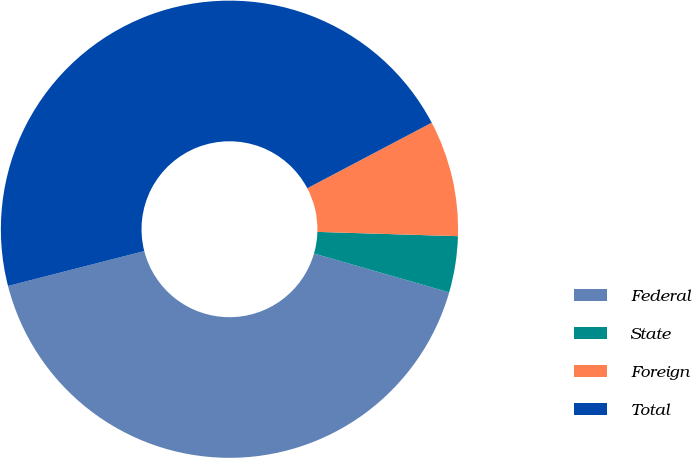<chart> <loc_0><loc_0><loc_500><loc_500><pie_chart><fcel>Federal<fcel>State<fcel>Foreign<fcel>Total<nl><fcel>41.56%<fcel>3.97%<fcel>8.2%<fcel>46.28%<nl></chart> 